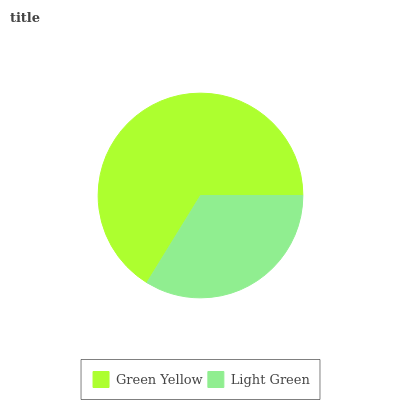Is Light Green the minimum?
Answer yes or no. Yes. Is Green Yellow the maximum?
Answer yes or no. Yes. Is Light Green the maximum?
Answer yes or no. No. Is Green Yellow greater than Light Green?
Answer yes or no. Yes. Is Light Green less than Green Yellow?
Answer yes or no. Yes. Is Light Green greater than Green Yellow?
Answer yes or no. No. Is Green Yellow less than Light Green?
Answer yes or no. No. Is Green Yellow the high median?
Answer yes or no. Yes. Is Light Green the low median?
Answer yes or no. Yes. Is Light Green the high median?
Answer yes or no. No. Is Green Yellow the low median?
Answer yes or no. No. 